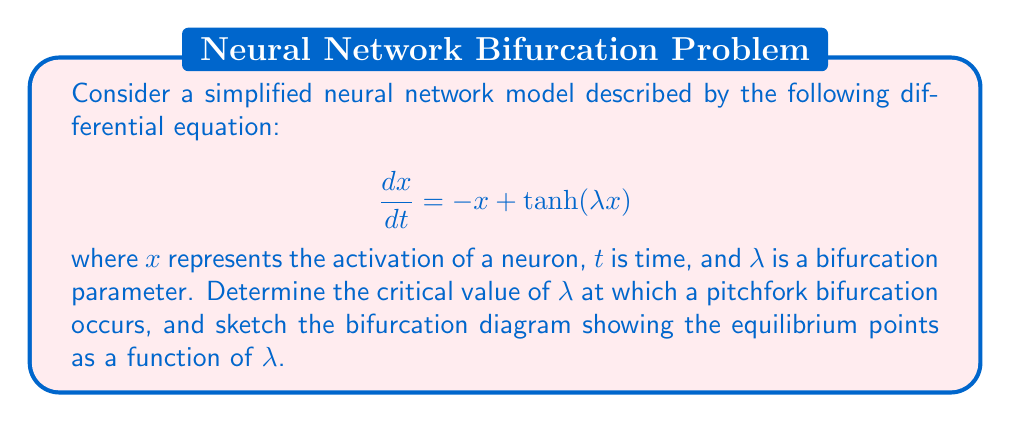Show me your answer to this math problem. 1) First, we need to find the equilibrium points of the system. These occur when $\frac{dx}{dt} = 0$:

   $$0 = -x + \tanh(\lambda x)$$

2) For small values of $\lambda$, there is only one equilibrium point at $x = 0$. As $\lambda$ increases, new equilibrium points may appear.

3) To find the bifurcation point, we need to analyze the stability of the $x = 0$ equilibrium. We can do this by linearizing the system around $x = 0$:

   $$\frac{dx}{dt} \approx (-1 + \lambda)x$$

4) The stability changes when $-1 + \lambda = 0$, or when $\lambda = 1$. This is the critical point where the pitchfork bifurcation occurs.

5) For $\lambda < 1$, $x = 0$ is stable. For $\lambda > 1$, $x = 0$ becomes unstable, and two new stable equilibrium points appear.

6) To find these new equilibrium points for $\lambda > 1$, we can use the approximation $\tanh(x) \approx x - \frac{1}{3}x^3$ for small $x$:

   $$0 = -x + \lambda x - \frac{1}{3}\lambda x^3$$
   $$\frac{1}{3}\lambda x^3 - (\lambda - 1)x = 0$$
   $$x(x^2 - \frac{3(\lambda - 1)}{\lambda}) = 0$$

7) Solving this, we get:

   $$x = 0, \quad x = \pm \sqrt{\frac{3(\lambda - 1)}{\lambda}}$$

8) The bifurcation diagram would look like this:

[asy]
import graph;
size(200,200);

real f(real x, real l) {
  return -x + tanh(l*x);
}

for (real l=0; l<=2; l+=0.1) {
  for (real x=-2; x<=2; x+=0.01) {
    if (abs(f(x,l)) < 0.01) {
      dot((l,x), blue);
    }
  }
}

xaxis("λ",Arrow);
yaxis("x",Arrow);
label("1",(1,0),S);
</asy]
Answer: $\lambda_c = 1$ 